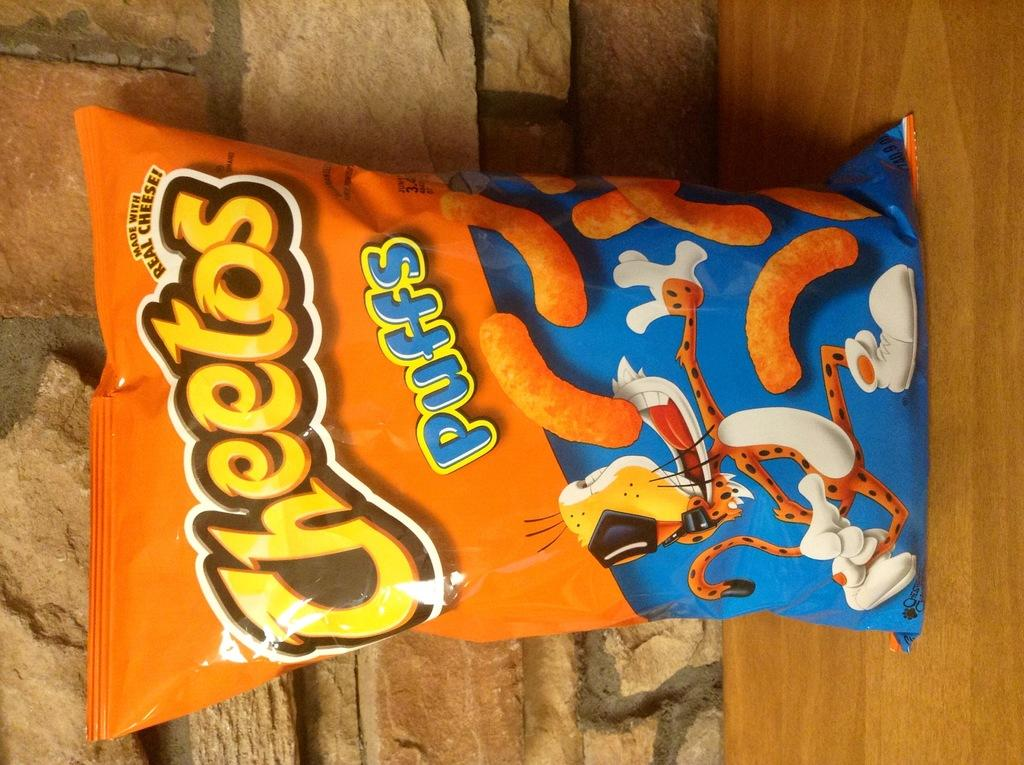What is present on the wooden surface in the image? There is a packet on the wooden surface in the image. What can be seen on the packet? There is writing on the packet. What is visible in the background of the image? There is a wall in the background of the image. What type of pancake is being served on the wooden surface in the image? There is no pancake present in the image; it only features a packet on a wooden surface. Can you tell me the make and model of the car parked in front of the wall in the image? There is no car present in the image; it only features a wall in the background. 